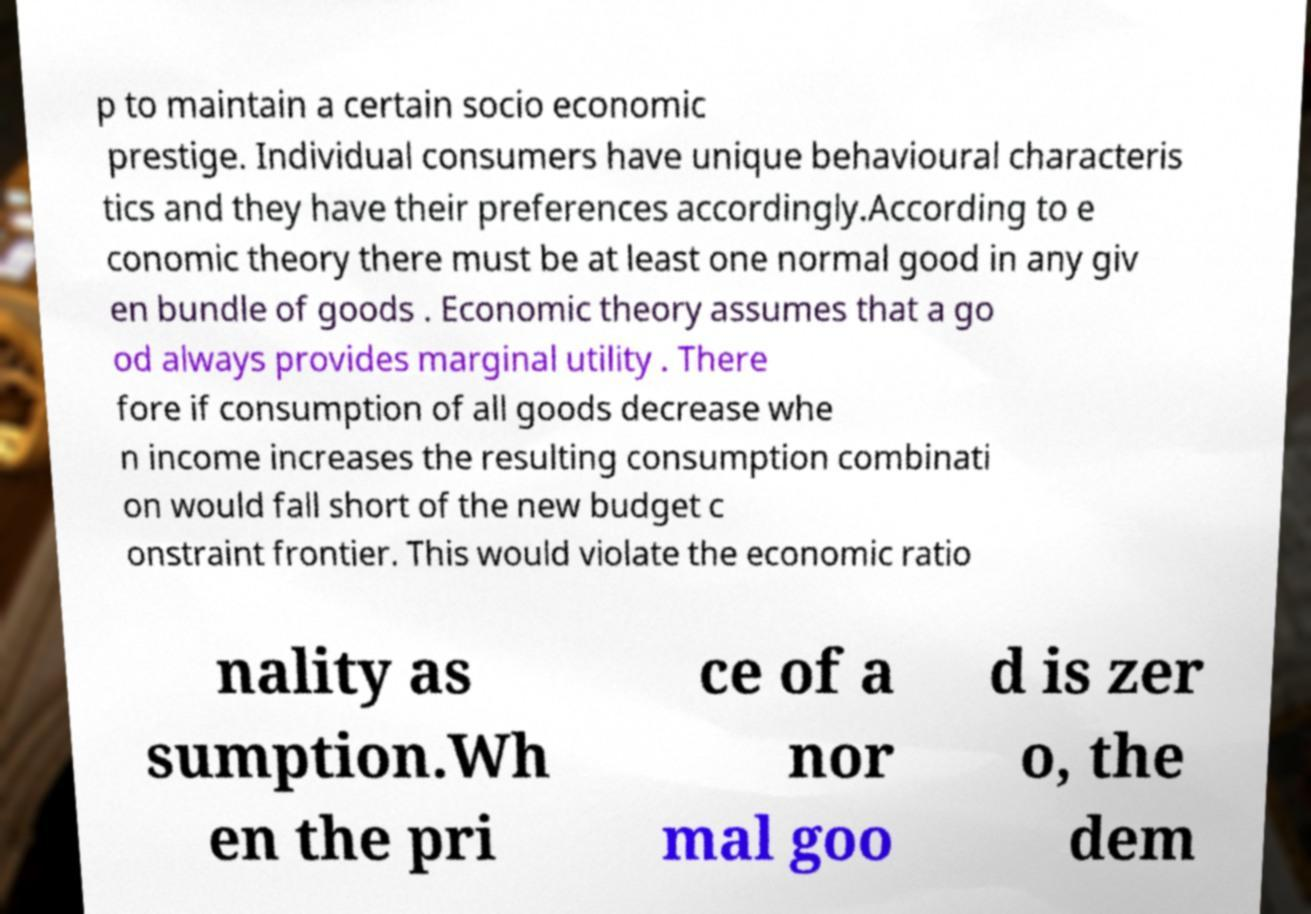There's text embedded in this image that I need extracted. Can you transcribe it verbatim? p to maintain a certain socio economic prestige. Individual consumers have unique behavioural characteris tics and they have their preferences accordingly.According to e conomic theory there must be at least one normal good in any giv en bundle of goods . Economic theory assumes that a go od always provides marginal utility . There fore if consumption of all goods decrease whe n income increases the resulting consumption combinati on would fall short of the new budget c onstraint frontier. This would violate the economic ratio nality as sumption.Wh en the pri ce of a nor mal goo d is zer o, the dem 